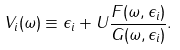<formula> <loc_0><loc_0><loc_500><loc_500>V _ { i } ( \omega ) \equiv \epsilon _ { i } + U \frac { F ( \omega , \epsilon _ { i } ) } { G ( \omega , \epsilon _ { i } ) } .</formula> 